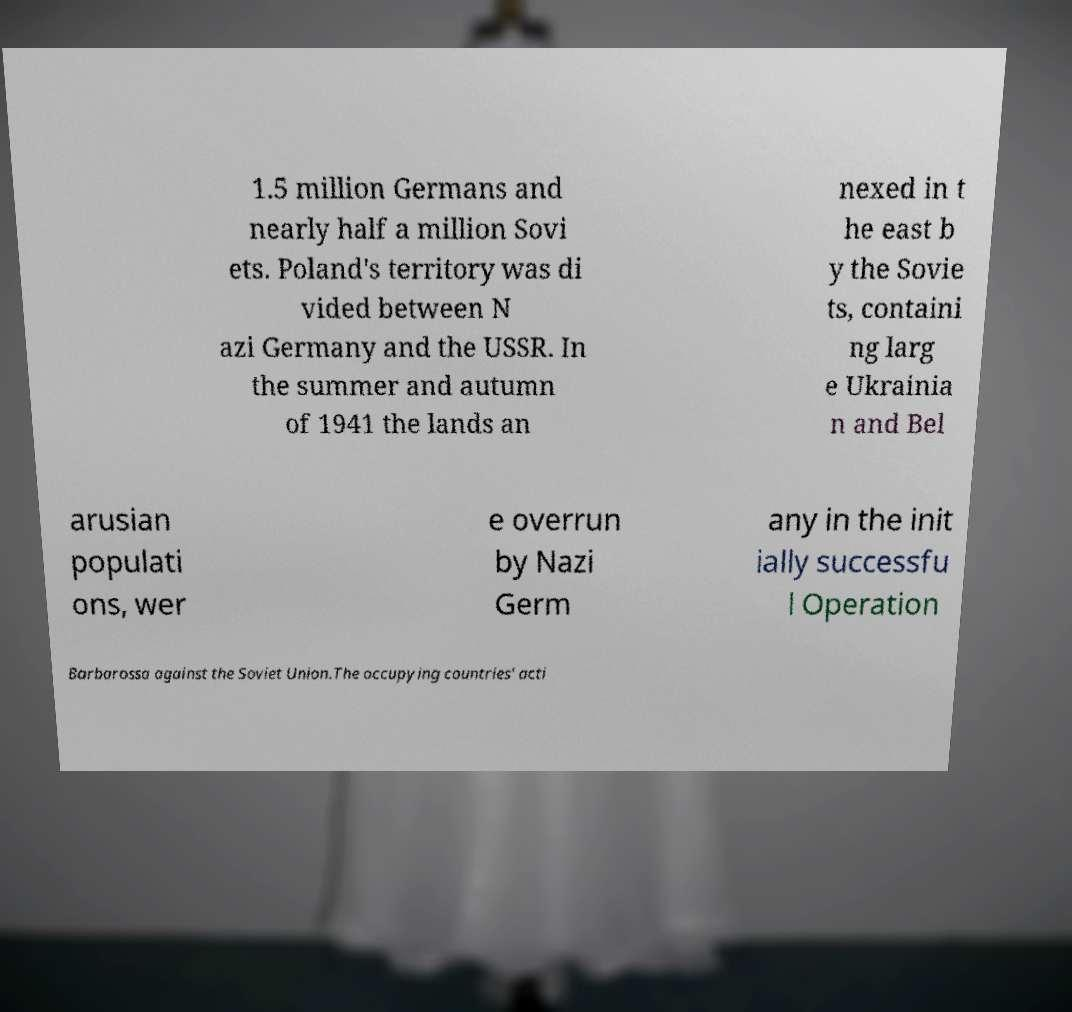Please read and relay the text visible in this image. What does it say? 1.5 million Germans and nearly half a million Sovi ets. Poland's territory was di vided between N azi Germany and the USSR. In the summer and autumn of 1941 the lands an nexed in t he east b y the Sovie ts, containi ng larg e Ukrainia n and Bel arusian populati ons, wer e overrun by Nazi Germ any in the init ially successfu l Operation Barbarossa against the Soviet Union.The occupying countries' acti 